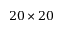Convert formula to latex. <formula><loc_0><loc_0><loc_500><loc_500>2 0 \times 2 0</formula> 